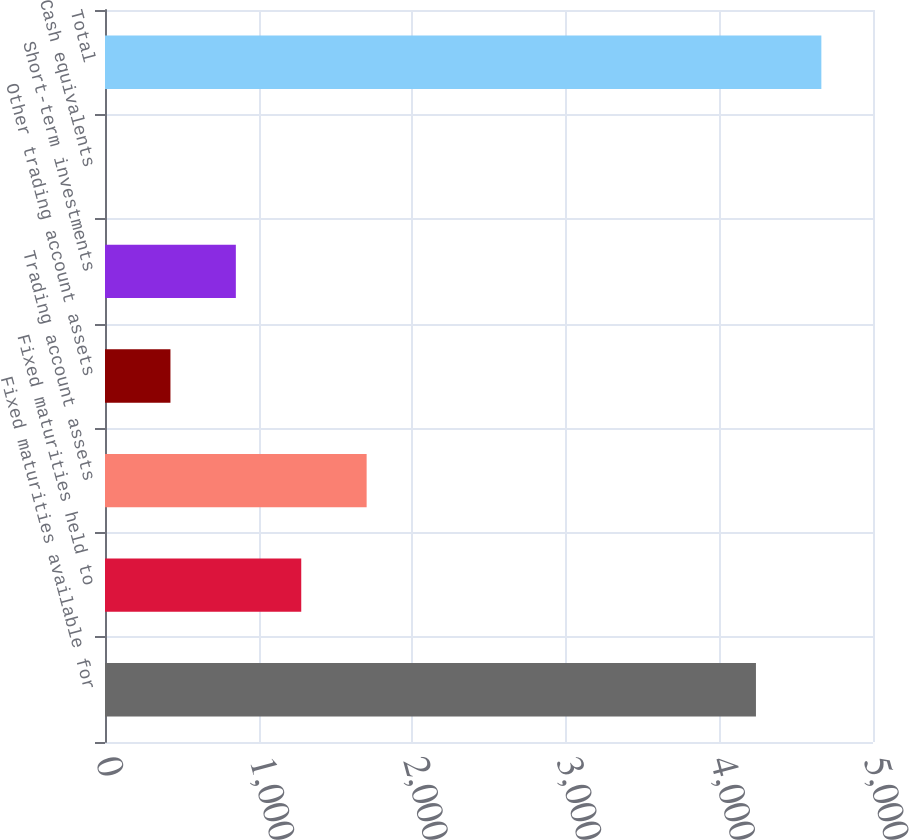<chart> <loc_0><loc_0><loc_500><loc_500><bar_chart><fcel>Fixed maturities available for<fcel>Fixed maturities held to<fcel>Trading account assets<fcel>Other trading account assets<fcel>Short-term investments<fcel>Cash equivalents<fcel>Total<nl><fcel>4238<fcel>1277.62<fcel>1703.39<fcel>426.08<fcel>851.85<fcel>0.31<fcel>4663.77<nl></chart> 